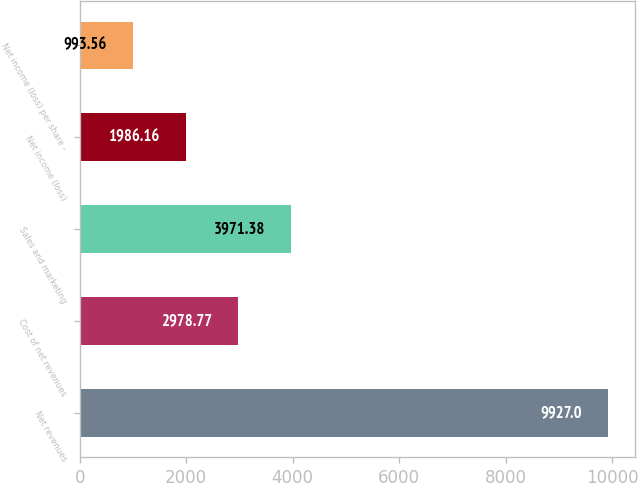<chart> <loc_0><loc_0><loc_500><loc_500><bar_chart><fcel>Net revenues<fcel>Cost of net revenues<fcel>Sales and marketing<fcel>Net income (loss)<fcel>Net income (loss) per share -<nl><fcel>9927<fcel>2978.77<fcel>3971.38<fcel>1986.16<fcel>993.56<nl></chart> 